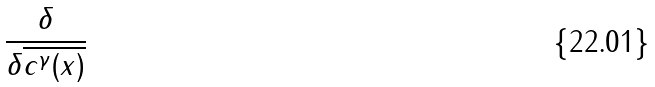Convert formula to latex. <formula><loc_0><loc_0><loc_500><loc_500>\frac { \delta } { \delta \overline { { { c ^ { \gamma } ( x ) } } } }</formula> 